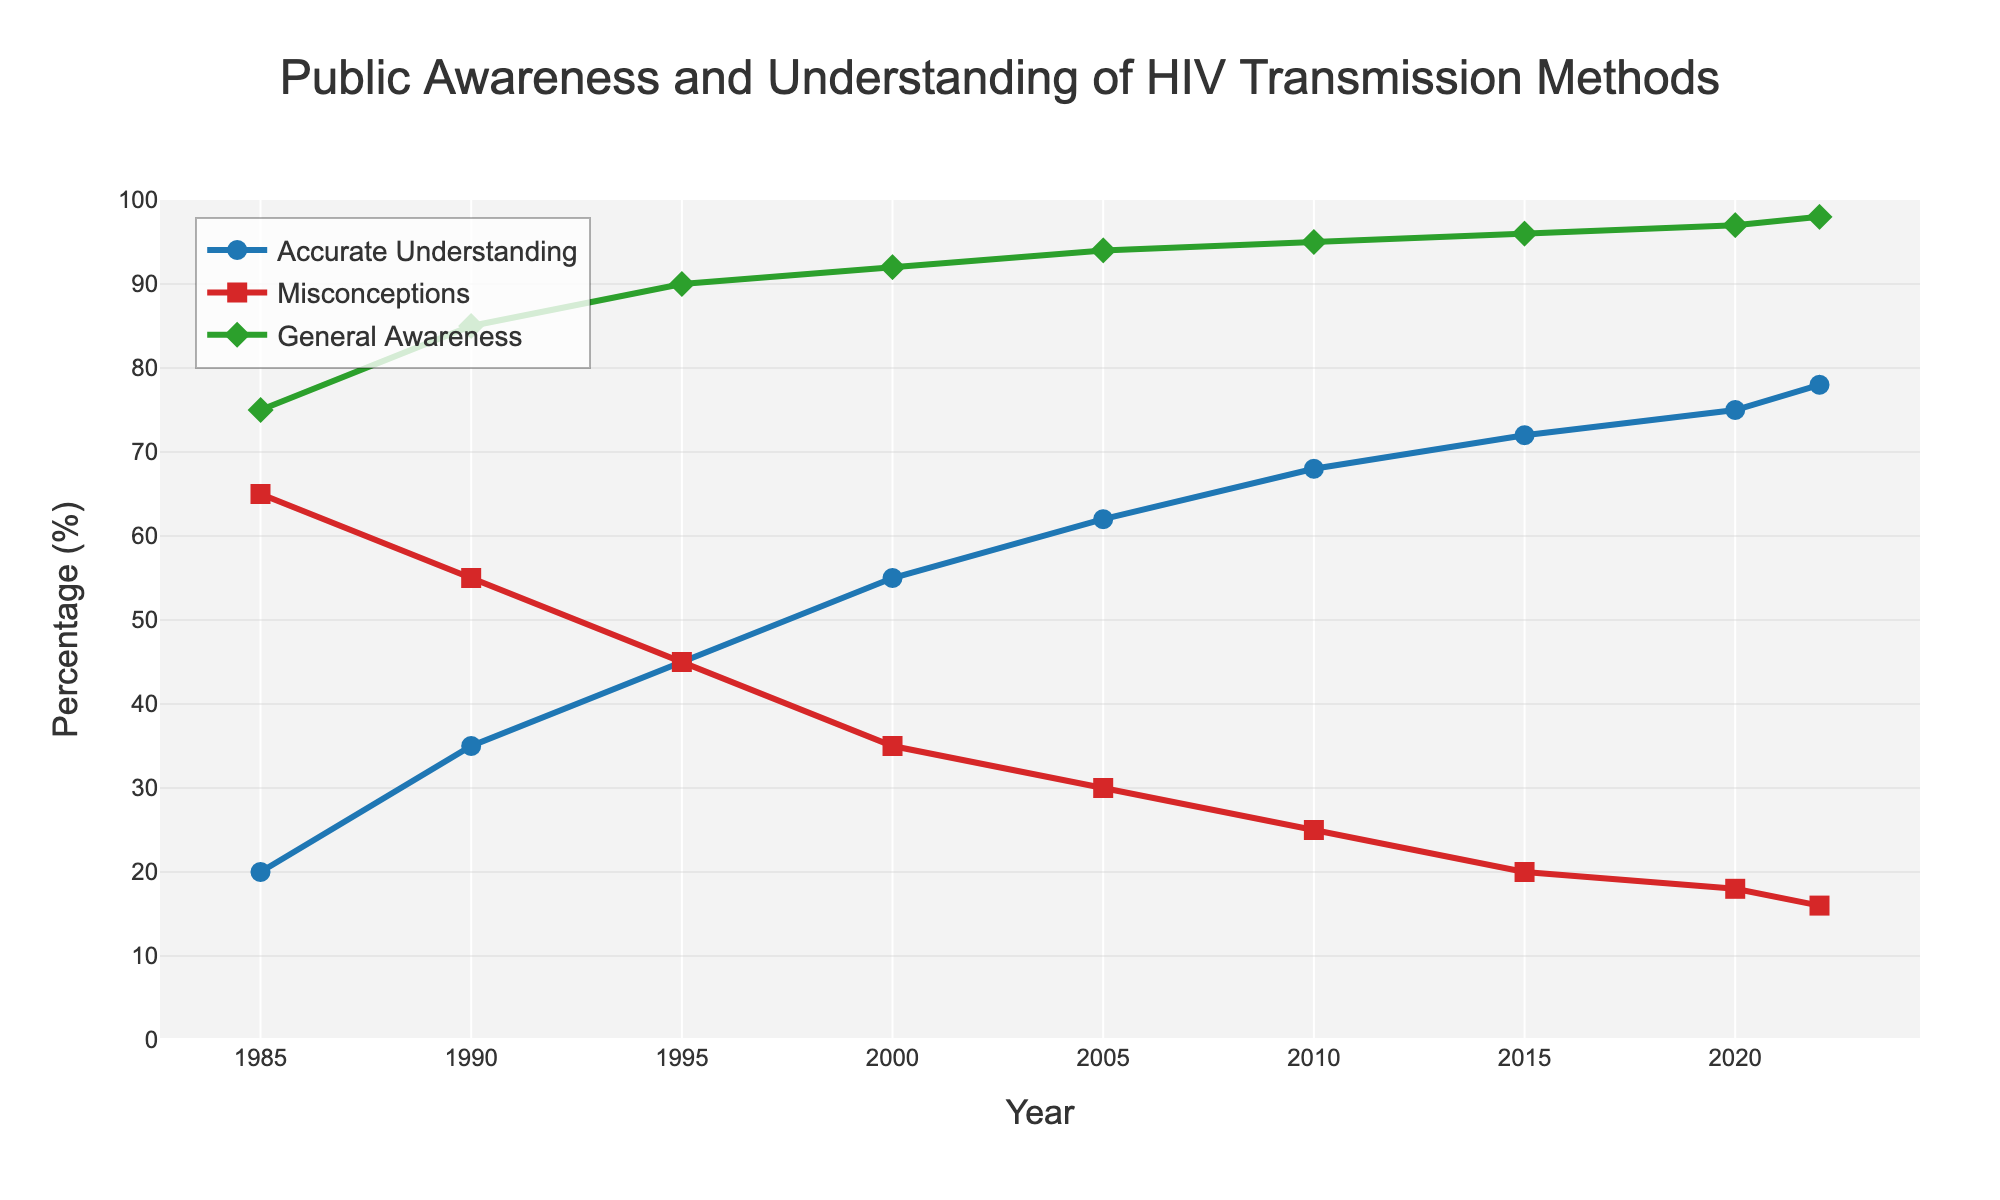What's the trend in Accurate Understanding from 1985 to 2022? To determine the trend in Accurate Understanding, look at the line marked 'Accurate Understanding' over the years. The line shows a consistent increase from 20% in 1985 to 78% in 2022.
Answer: Increasing Which year had the highest percentage of Misconceptions? To identify the highest percentage of Misconceptions, examine the line marked 'Misconceptions' and find the peak value. In 1985, the Misconceptions percentage was highest at 65%.
Answer: 1985 In what year did General Awareness first reach 95% or above? To find the year General Awareness reached 95%, examine the 'General Awareness' line and find the first data point at or above 95%. This occurs in 2010, where General Awareness was 95%.
Answer: 2010 By how much did Accurate Understanding increase between 1985 and 2000? Subtract the percentage of Accurate Understanding in 1985 from the percentage in 2000 (55% - 20%). The increase is (55 - 20)%.
Answer: 35% Between which consecutive years did Misconceptions decrease the most? To determine the greatest decline in Misconceptions, compare the percentage decrease between consecutive years. The greatest decrease occurs between 1990 (55%) and 1995 (45%), a 10% reduction.
Answer: 1990-1995 Compare the General Awareness in 2000 and 2020. Which year had a higher percentage and by how much? Look at the 'General Awareness' values for 2000 and 2020. In 2000, it was 92%, and in 2020, it was 97%. The difference is (97% - 92%), a 5% increase.
Answer: 2020 by 5% What is the average percentage of Accurate Understanding over the period? Add the percentages of Accurate Understanding for all years and divide by the number of data points. Sum: 20 + 35 + 45 + 55 + 62 + 68 + 72 + 75 + 78 = 510. The average is 510 / 9.
Answer: 56.67% What percentage difference is there between Misconceptions and Accurate Understanding in 2022? Subtract Accurate Understanding (78%) from Misconceptions (16%) in 2022. The difference is 78% - 16%.
Answer: 62% What color represents the Accurate Understanding line in the chart? Identify the color of the line labeled 'Accurate Understanding.' The line is blue.
Answer: Blue In which year did all three measures (Acute Understanding, Misconceptions, and General Awareness) most closely converge? Analyze the chart for the year in which the three lines are closest. This occurs around 1995.
Answer: 1995 